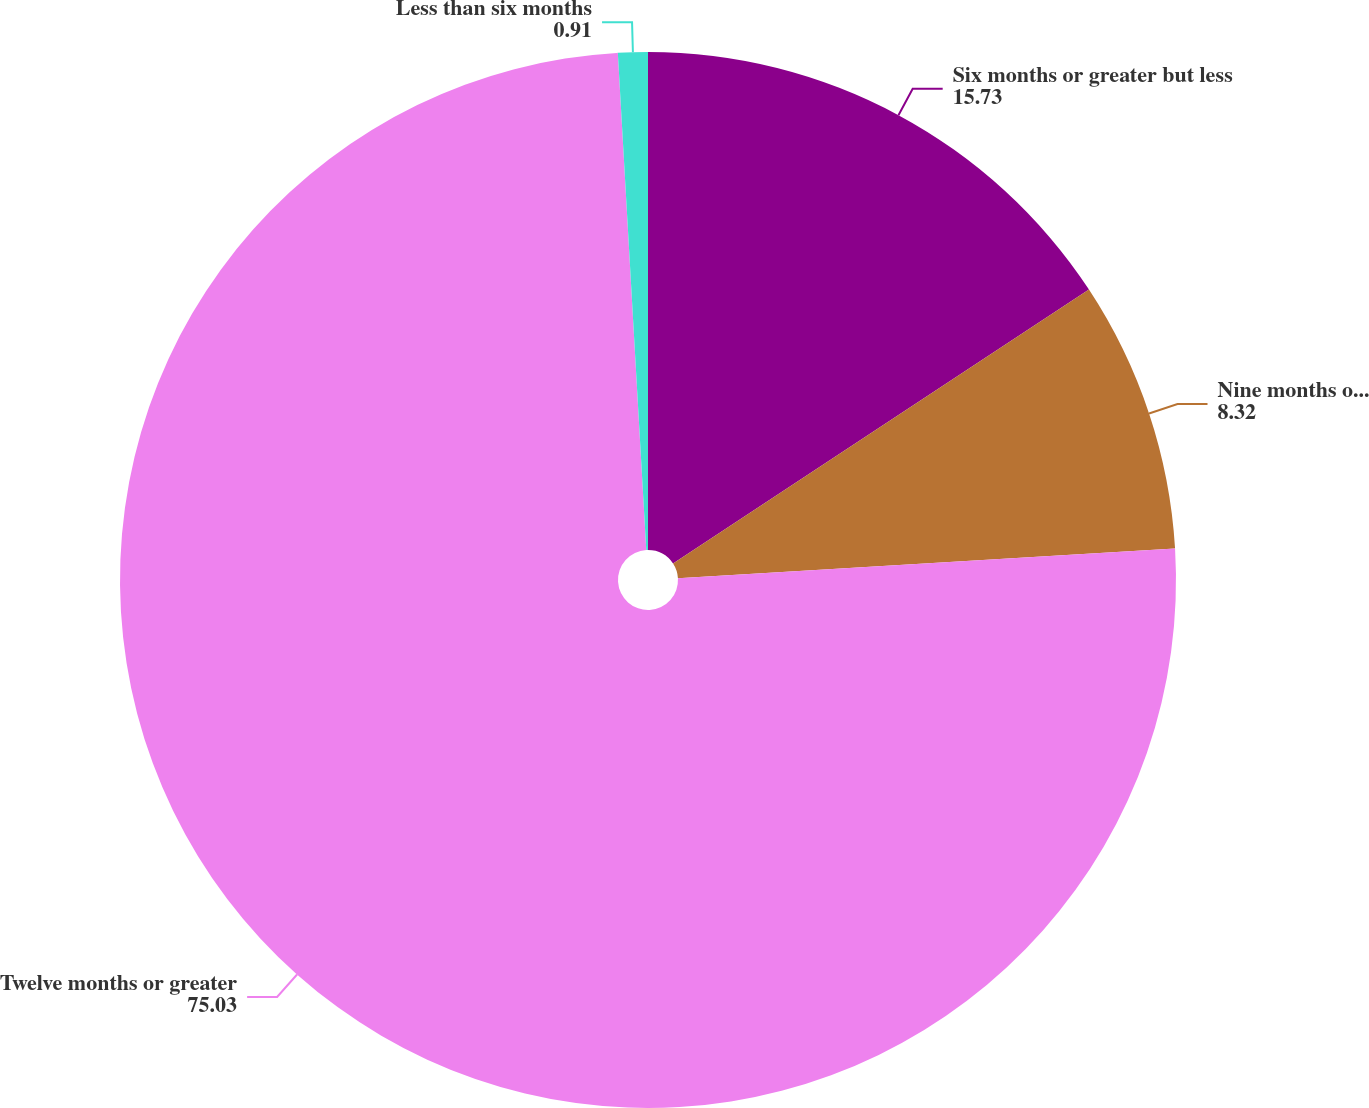Convert chart. <chart><loc_0><loc_0><loc_500><loc_500><pie_chart><fcel>Six months or greater but less<fcel>Nine months or greater but<fcel>Twelve months or greater<fcel>Less than six months<nl><fcel>15.73%<fcel>8.32%<fcel>75.03%<fcel>0.91%<nl></chart> 